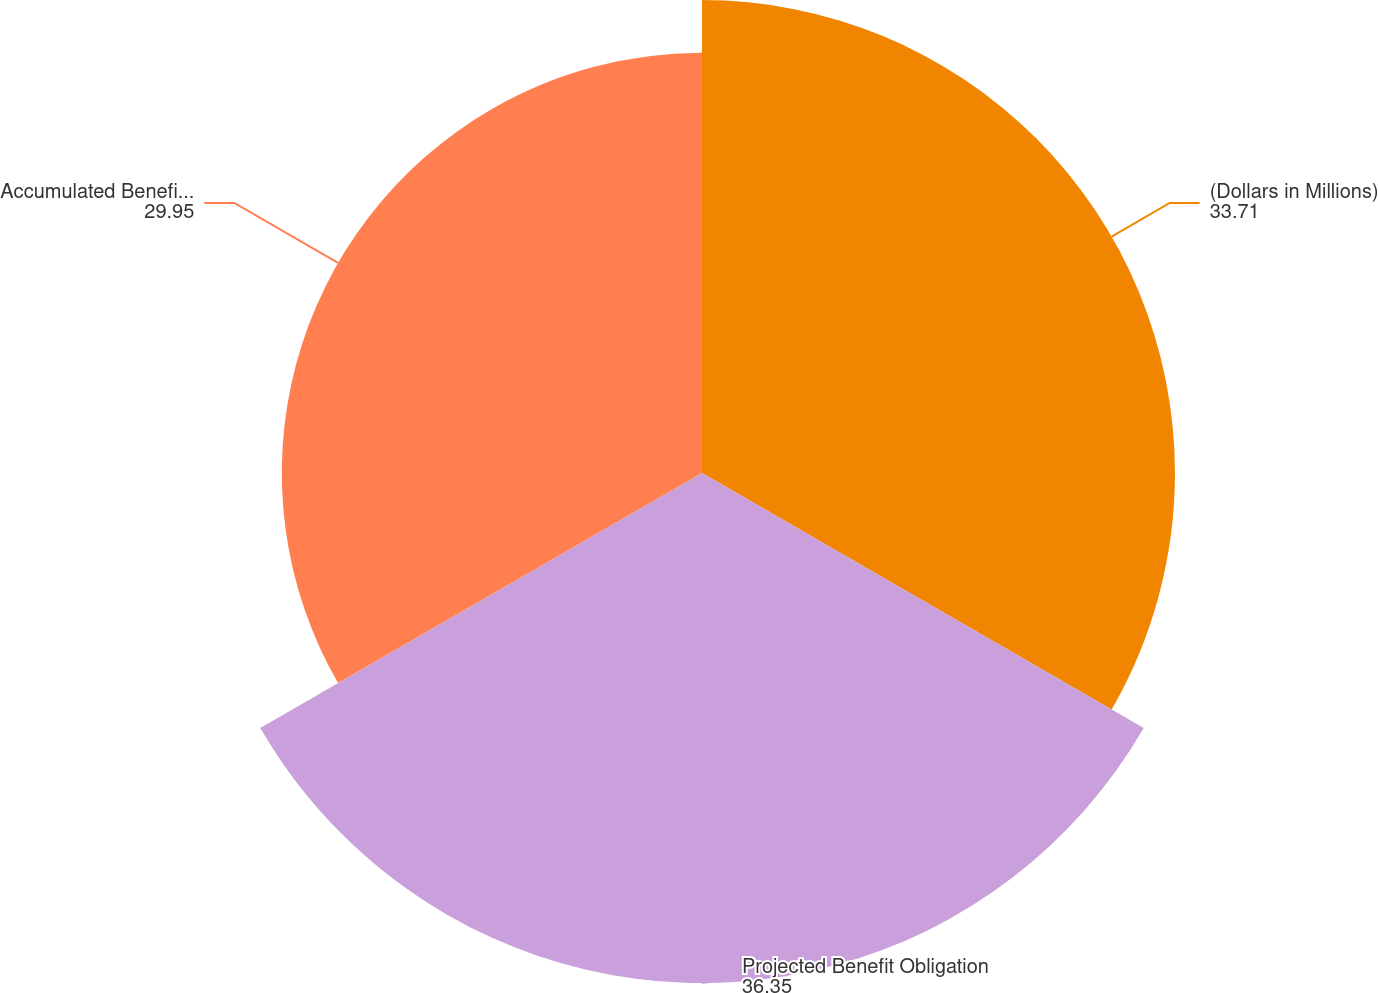<chart> <loc_0><loc_0><loc_500><loc_500><pie_chart><fcel>(Dollars in Millions)<fcel>Projected Benefit Obligation<fcel>Accumulated Benefit Obligation<nl><fcel>33.71%<fcel>36.35%<fcel>29.95%<nl></chart> 